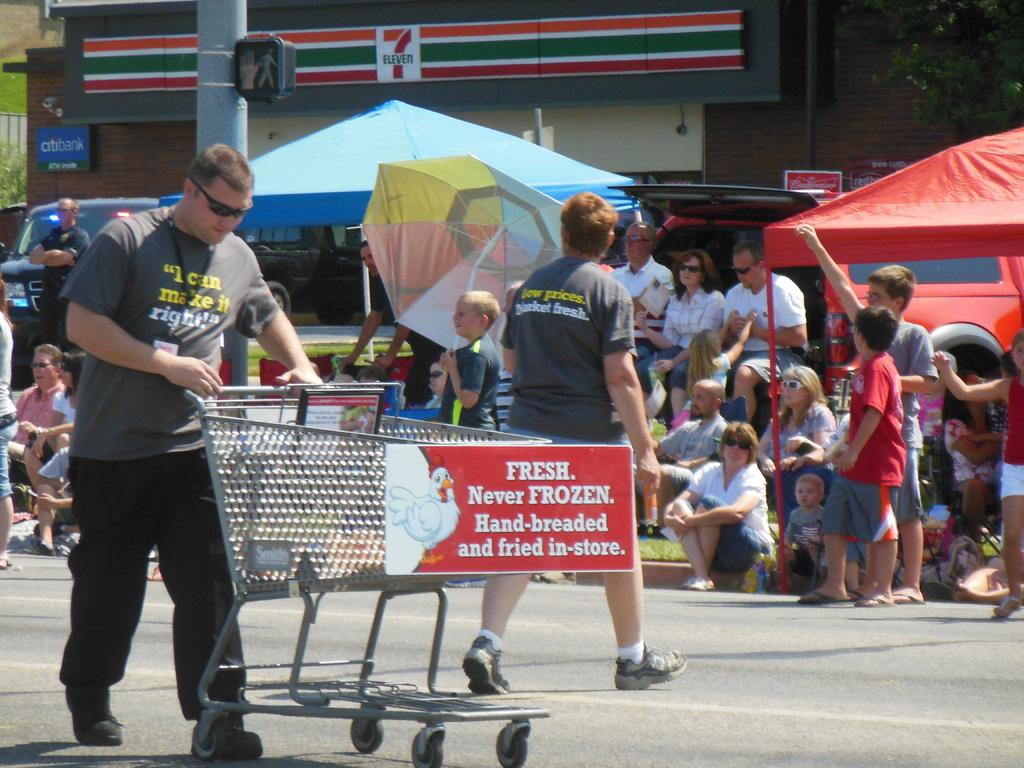What is the man in the image doing? There is a man walking on the road in the image. What is the man holding while walking? The man is holding a trolley. Can you describe the other person in the image? There is another man beside the first man. What are some of the other people in the image doing? Some people are sitting under a tent. What type of structure is visible in the image? There is a building in the image. What type of insect is sitting on the actor's shoulder in the image? There is no actor or insect present in the image. How many cars can be seen in the image? There are no cars visible in the image. 